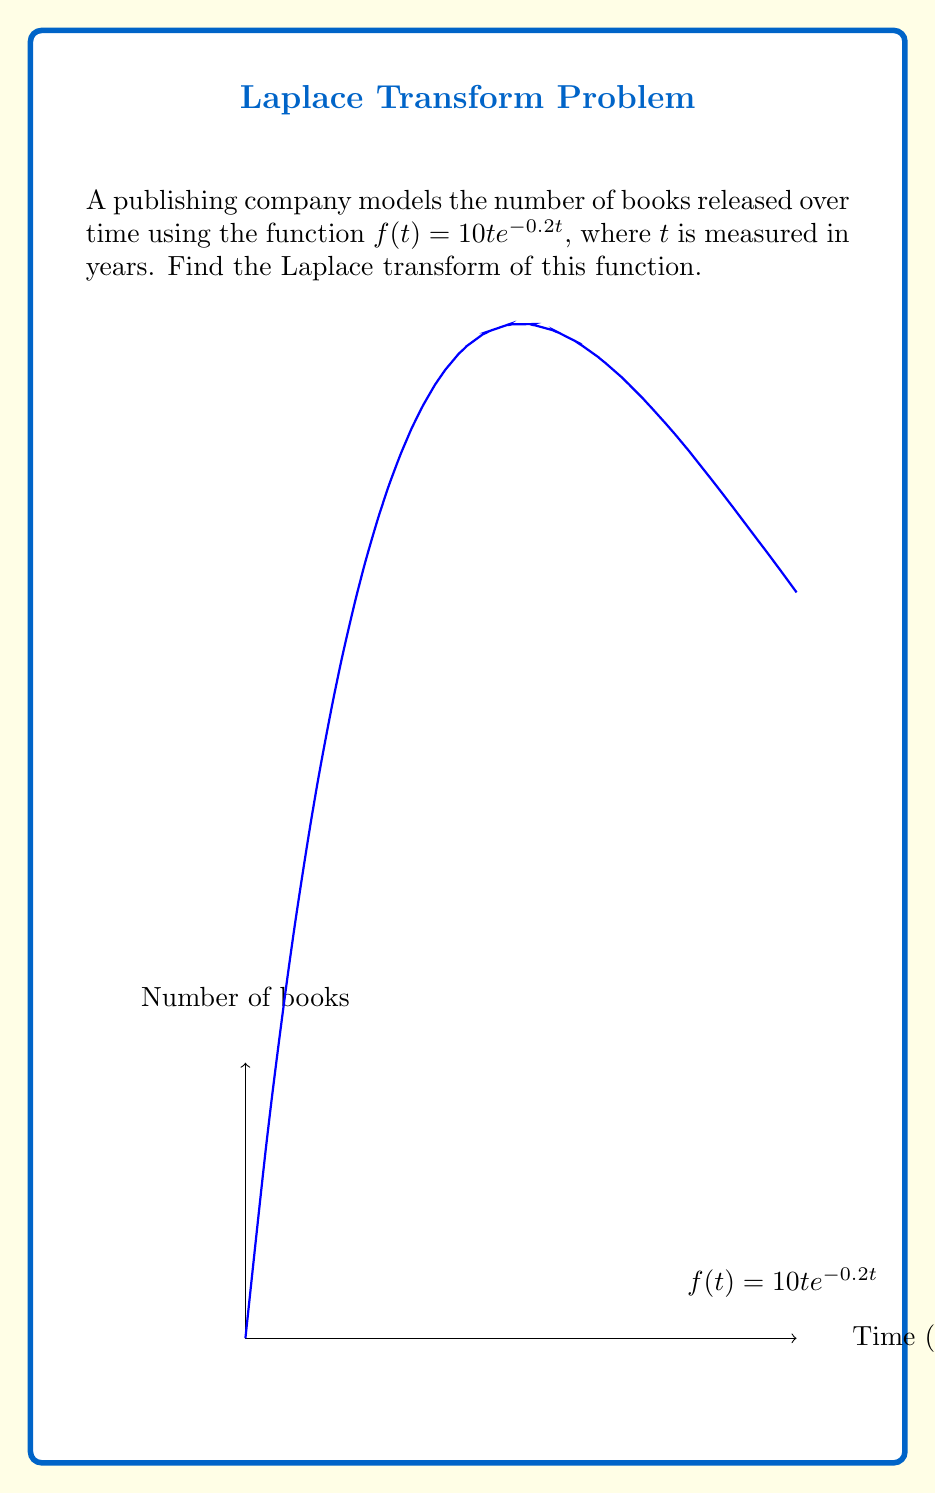Could you help me with this problem? To find the Laplace transform of $f(t) = 10t e^{-0.2t}$, we'll follow these steps:

1) The Laplace transform is defined as:
   $$\mathcal{L}\{f(t)\} = F(s) = \int_0^\infty f(t) e^{-st} dt$$

2) Substituting our function:
   $$F(s) = \int_0^\infty 10t e^{-0.2t} e^{-st} dt$$

3) Simplify the integrand:
   $$F(s) = 10 \int_0^\infty t e^{-(s+0.2)t} dt$$

4) This integral is of the form $\int_0^\infty t e^{-at} dt$, which has a known solution:
   $$\int_0^\infty t e^{-at} dt = \frac{1}{a^2}$$

5) In our case, $a = s + 0.2$. Substituting:
   $$F(s) = 10 \cdot \frac{1}{(s+0.2)^2}$$

6) Simplify:
   $$F(s) = \frac{10}{(s+0.2)^2}$$

This is the Laplace transform of the given publishing timeline function.
Answer: $$\frac{10}{(s+0.2)^2}$$ 